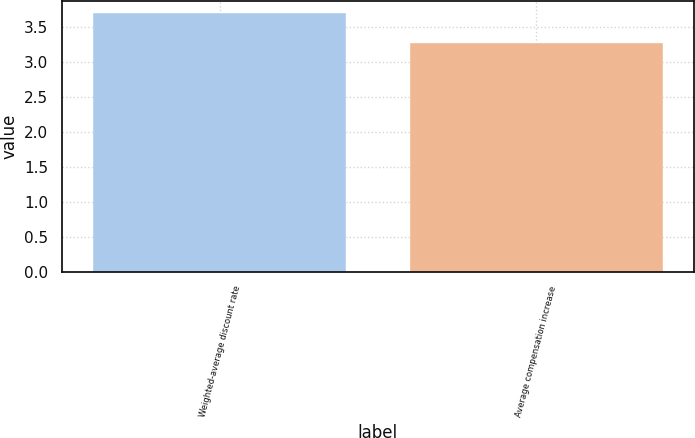Convert chart to OTSL. <chart><loc_0><loc_0><loc_500><loc_500><bar_chart><fcel>Weighted-average discount rate<fcel>Average compensation increase<nl><fcel>3.7<fcel>3.27<nl></chart> 